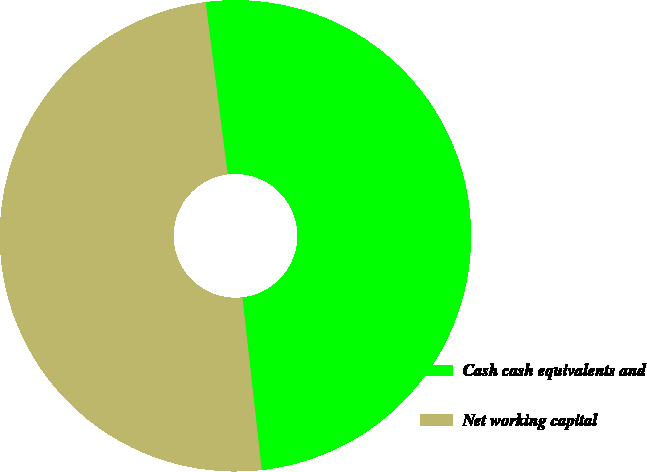Convert chart to OTSL. <chart><loc_0><loc_0><loc_500><loc_500><pie_chart><fcel>Cash cash equivalents and<fcel>Net working capital<nl><fcel>50.25%<fcel>49.75%<nl></chart> 